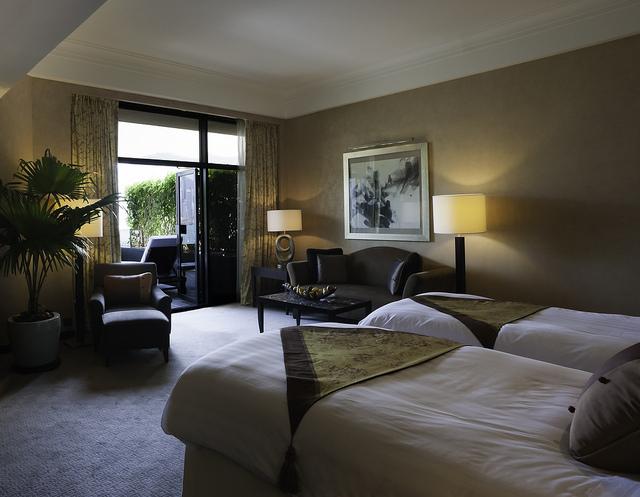How many beds in the room?
Quick response, please. 2. Is there any item in the room that shows a reflection?
Short answer required. No. Are the drapes open?
Answer briefly. Yes. Is there a patio outside?
Answer briefly. Yes. Is there a plant in the room?
Give a very brief answer. Yes. Is this bedroom lived in?
Concise answer only. No. Is this room on the ground floor?
Concise answer only. Yes. Does the couch have a slipcover?
Be succinct. No. 